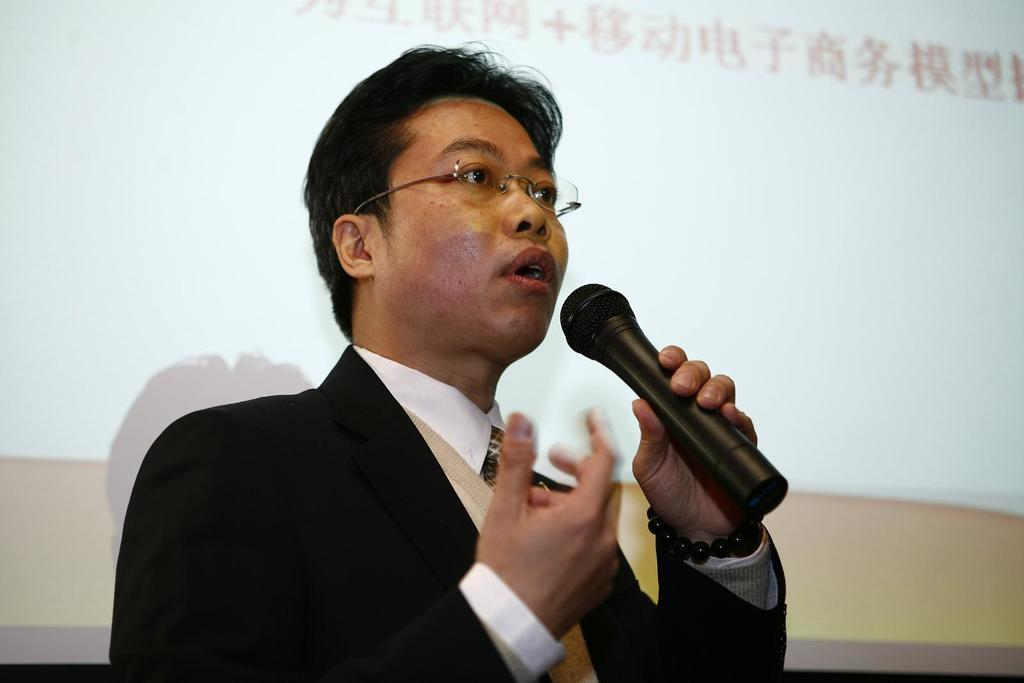What is the man in the image wearing? The man is wearing a suit. What is the man holding in the image? The man is holding a microphone. What is the man doing in the image? The man is talking. What can be seen in the background of the image? There is a screen in the background of the image. Can you describe the person in the background? There is a man in the background wearing glasses. How much is the amount of the receipt for the man's suit in the image? There is no receipt present in the image, so it is not possible to determine the amount. 